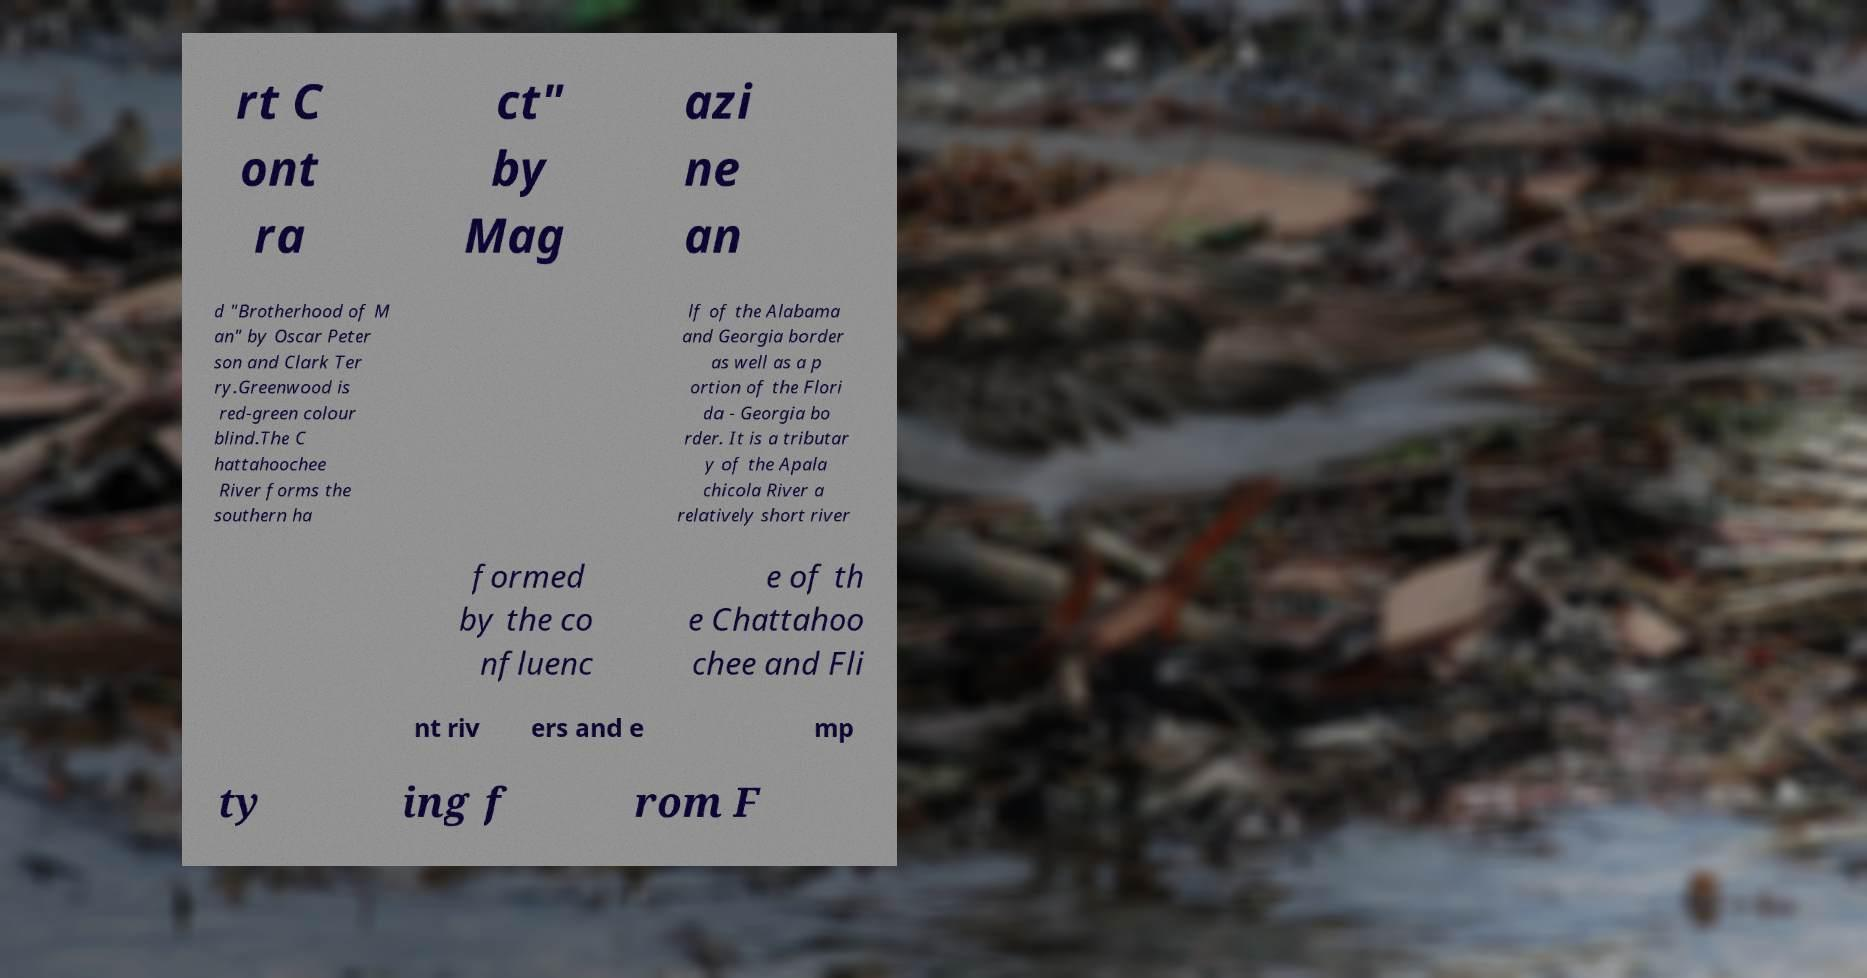What messages or text are displayed in this image? I need them in a readable, typed format. rt C ont ra ct" by Mag azi ne an d "Brotherhood of M an" by Oscar Peter son and Clark Ter ry.Greenwood is red-green colour blind.The C hattahoochee River forms the southern ha lf of the Alabama and Georgia border as well as a p ortion of the Flori da - Georgia bo rder. It is a tributar y of the Apala chicola River a relatively short river formed by the co nfluenc e of th e Chattahoo chee and Fli nt riv ers and e mp ty ing f rom F 